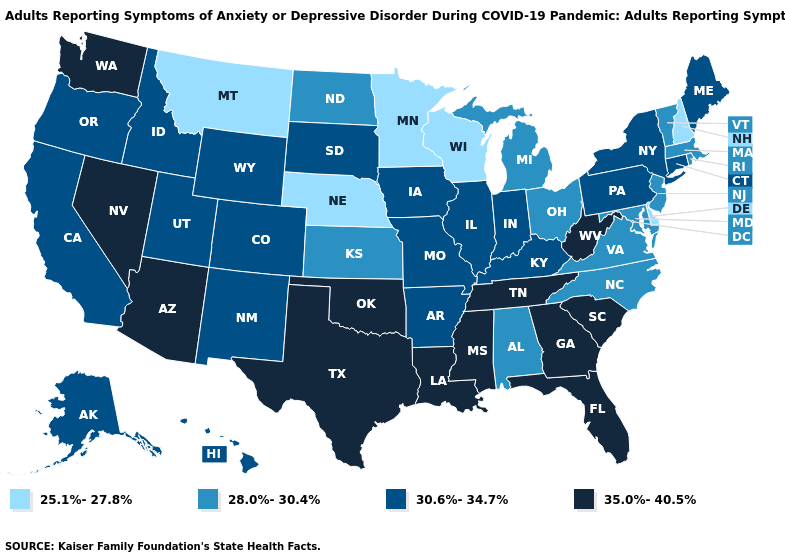Does Indiana have a lower value than North Carolina?
Keep it brief. No. Does the map have missing data?
Answer briefly. No. Among the states that border Iowa , which have the lowest value?
Keep it brief. Minnesota, Nebraska, Wisconsin. Name the states that have a value in the range 30.6%-34.7%?
Short answer required. Alaska, Arkansas, California, Colorado, Connecticut, Hawaii, Idaho, Illinois, Indiana, Iowa, Kentucky, Maine, Missouri, New Mexico, New York, Oregon, Pennsylvania, South Dakota, Utah, Wyoming. What is the value of Maine?
Short answer required. 30.6%-34.7%. Which states have the lowest value in the West?
Short answer required. Montana. Which states have the highest value in the USA?
Short answer required. Arizona, Florida, Georgia, Louisiana, Mississippi, Nevada, Oklahoma, South Carolina, Tennessee, Texas, Washington, West Virginia. Does North Carolina have a higher value than Delaware?
Keep it brief. Yes. Does Utah have the lowest value in the USA?
Quick response, please. No. What is the value of North Dakota?
Be succinct. 28.0%-30.4%. Does Michigan have a lower value than New York?
Give a very brief answer. Yes. Name the states that have a value in the range 30.6%-34.7%?
Concise answer only. Alaska, Arkansas, California, Colorado, Connecticut, Hawaii, Idaho, Illinois, Indiana, Iowa, Kentucky, Maine, Missouri, New Mexico, New York, Oregon, Pennsylvania, South Dakota, Utah, Wyoming. Does the first symbol in the legend represent the smallest category?
Concise answer only. Yes. Does Ohio have a higher value than Iowa?
Answer briefly. No. Does North Dakota have the highest value in the MidWest?
Keep it brief. No. 